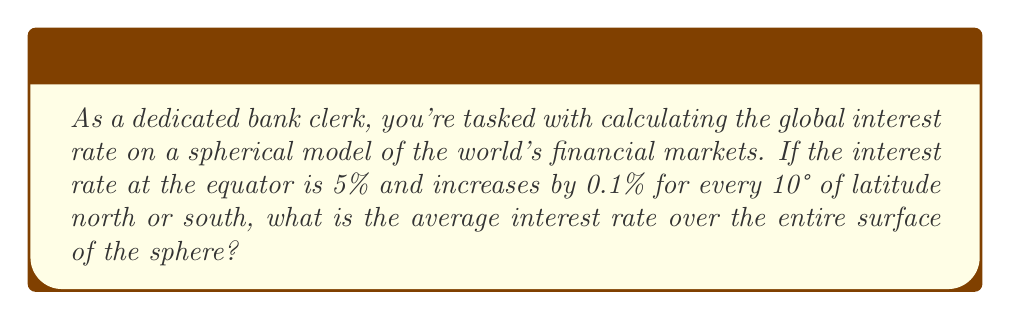What is the answer to this math problem? Let's approach this step-by-step:

1) First, we need to understand that on a sphere, the area of a latitude band is proportional to the cosine of the latitude angle.

2) The interest rate as a function of latitude θ can be expressed as:
   $r(\theta) = 5\% + 0.1\% \cdot \frac{|\theta|}{10°}$

3) To find the average interest rate, we need to integrate this function over the surface of the sphere:

   $$\bar{r} = \frac{\int_0^{\pi} \int_0^{2\pi} r(\theta) \sin\theta \, d\phi \, d\theta}{\int_0^{\pi} \int_0^{2\pi} \sin\theta \, d\phi \, d\theta}$$

4) Simplifying the numerator (the φ integral cancels out as r doesn't depend on φ):

   $$\bar{r} = \frac{\int_0^{\pi} r(\theta) \sin\theta \, d\theta}{\int_0^{\pi} \sin\theta \, d\theta}$$

5) Substituting our function for r(θ):

   $$\bar{r} = \frac{\int_0^{\pi} (5\% + 0.1\% \cdot \frac{\theta}{10°}) \sin\theta \, d\theta}{2}$$

6) Evaluating this integral:

   $$\bar{r} = \frac{1}{2} \left[5\% \cdot 2 + 0.1\% \cdot \frac{\pi}{10°}\right]$$

7) Simplifying:

   $$\bar{r} = 5\% + 0.1\% \cdot \frac{\pi}{20°}$$

8) Calculate the final value:

   $$\bar{r} \approx 5\% + 0.0157\% = 5.0157\%$$
Answer: 5.0157% 